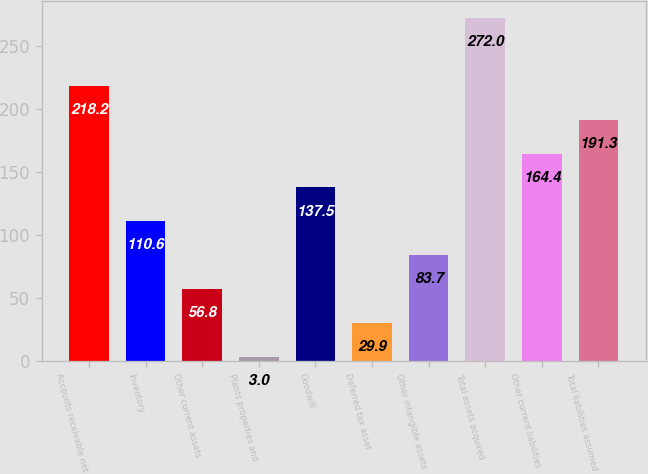<chart> <loc_0><loc_0><loc_500><loc_500><bar_chart><fcel>Accounts receivable net<fcel>Inventory<fcel>Other current assets<fcel>Plants properties and<fcel>Goodwill<fcel>Deferred tax asset<fcel>Other intangible assets<fcel>Total assets acquired<fcel>Other current liabilities<fcel>Total liabilities assumed<nl><fcel>218.2<fcel>110.6<fcel>56.8<fcel>3<fcel>137.5<fcel>29.9<fcel>83.7<fcel>272<fcel>164.4<fcel>191.3<nl></chart> 